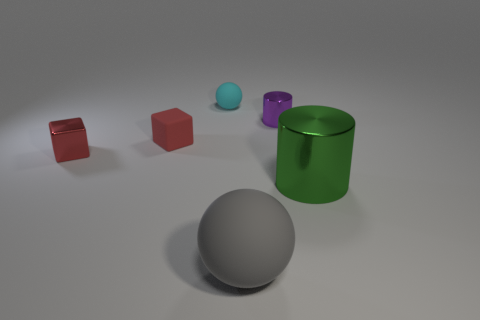Subtract all green cylinders. How many cylinders are left? 1 Add 1 tiny purple metallic cylinders. How many objects exist? 7 Subtract 2 balls. How many balls are left? 0 Subtract all rubber spheres. Subtract all large balls. How many objects are left? 3 Add 6 large gray objects. How many large gray objects are left? 7 Add 3 big blue matte spheres. How many big blue matte spheres exist? 3 Subtract 0 green spheres. How many objects are left? 6 Subtract all blocks. How many objects are left? 4 Subtract all blue spheres. Subtract all blue cylinders. How many spheres are left? 2 Subtract all cyan balls. How many cyan blocks are left? 0 